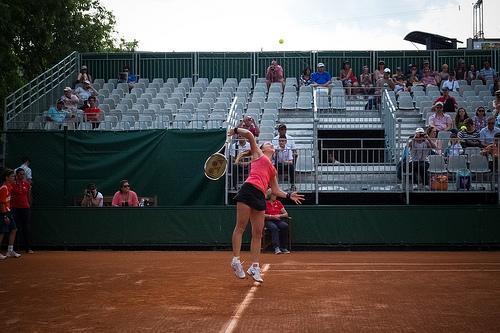How many players are there?
Give a very brief answer. 1. 